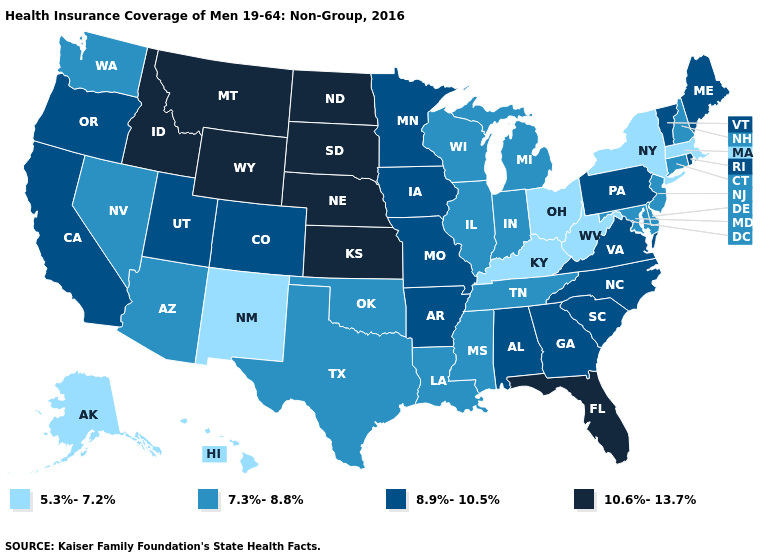Does Montana have the lowest value in the USA?
Write a very short answer. No. Does Oklahoma have a lower value than Tennessee?
Write a very short answer. No. Does New York have the lowest value in the USA?
Answer briefly. Yes. What is the value of New Hampshire?
Give a very brief answer. 7.3%-8.8%. What is the value of Montana?
Answer briefly. 10.6%-13.7%. Does Idaho have the highest value in the West?
Be succinct. Yes. What is the lowest value in the South?
Be succinct. 5.3%-7.2%. Does Maine have a lower value than Illinois?
Concise answer only. No. Does Oklahoma have a lower value than Arkansas?
Give a very brief answer. Yes. Name the states that have a value in the range 5.3%-7.2%?
Give a very brief answer. Alaska, Hawaii, Kentucky, Massachusetts, New Mexico, New York, Ohio, West Virginia. Does Kentucky have the lowest value in the South?
Short answer required. Yes. Among the states that border South Carolina , which have the lowest value?
Give a very brief answer. Georgia, North Carolina. Does California have the same value as Louisiana?
Give a very brief answer. No. Does New York have the lowest value in the USA?
Write a very short answer. Yes. Name the states that have a value in the range 5.3%-7.2%?
Short answer required. Alaska, Hawaii, Kentucky, Massachusetts, New Mexico, New York, Ohio, West Virginia. 